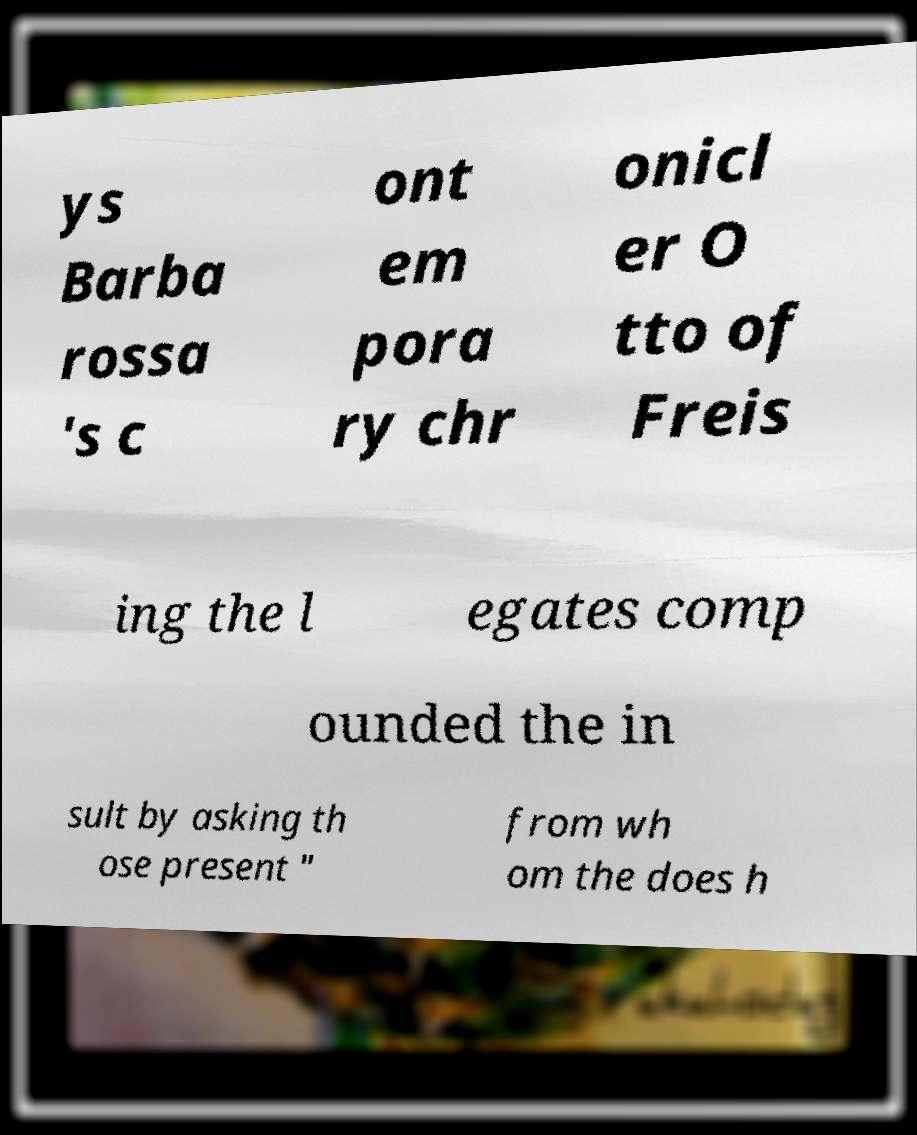What messages or text are displayed in this image? I need them in a readable, typed format. ys Barba rossa 's c ont em pora ry chr onicl er O tto of Freis ing the l egates comp ounded the in sult by asking th ose present " from wh om the does h 